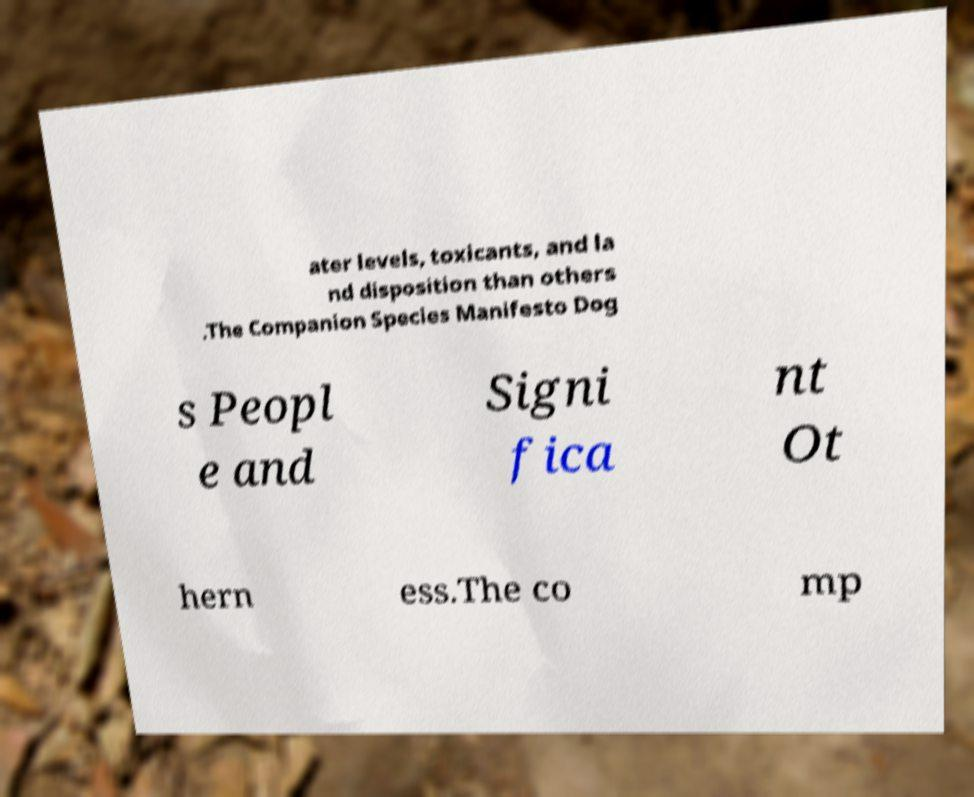Can you read and provide the text displayed in the image?This photo seems to have some interesting text. Can you extract and type it out for me? ater levels, toxicants, and la nd disposition than others .The Companion Species Manifesto Dog s Peopl e and Signi fica nt Ot hern ess.The co mp 